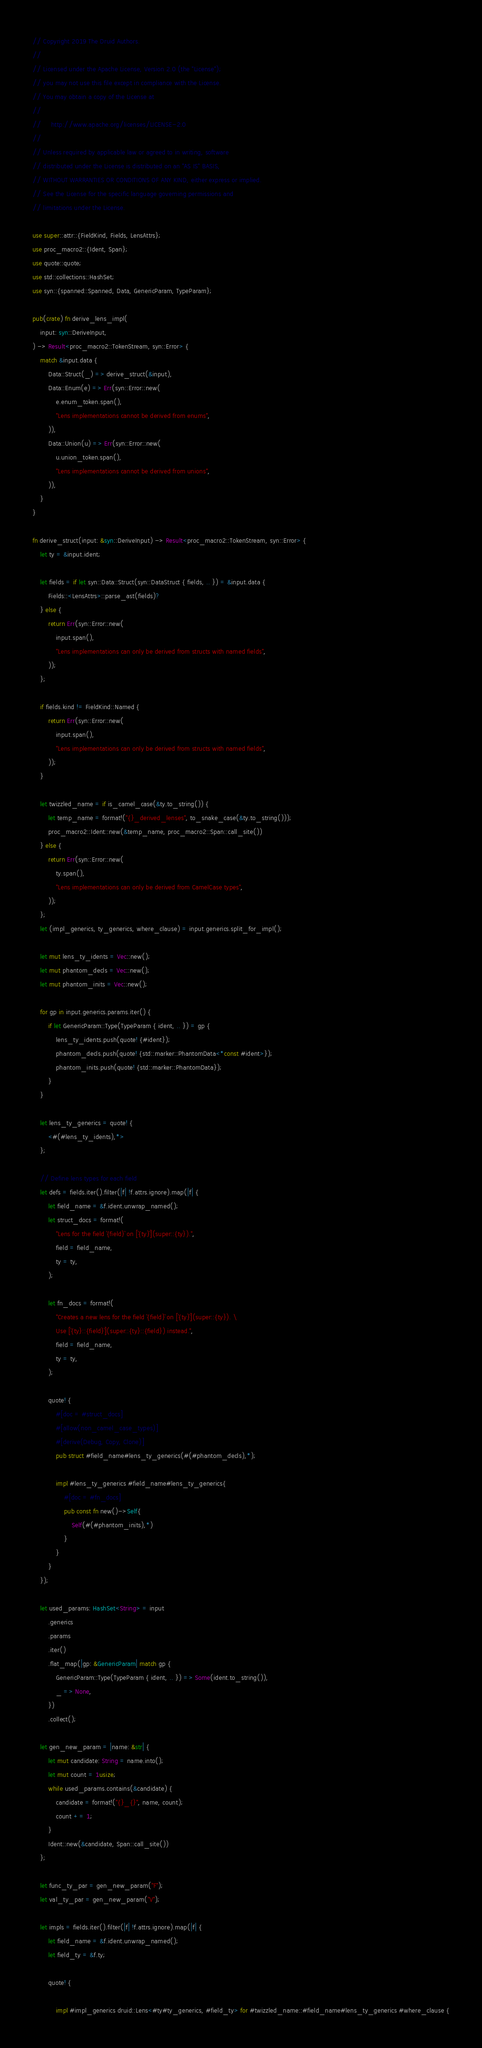<code> <loc_0><loc_0><loc_500><loc_500><_Rust_>// Copyright 2019 The Druid Authors.
//
// Licensed under the Apache License, Version 2.0 (the "License");
// you may not use this file except in compliance with the License.
// You may obtain a copy of the License at
//
//     http://www.apache.org/licenses/LICENSE-2.0
//
// Unless required by applicable law or agreed to in writing, software
// distributed under the License is distributed on an "AS IS" BASIS,
// WITHOUT WARRANTIES OR CONDITIONS OF ANY KIND, either express or implied.
// See the License for the specific language governing permissions and
// limitations under the License.

use super::attr::{FieldKind, Fields, LensAttrs};
use proc_macro2::{Ident, Span};
use quote::quote;
use std::collections::HashSet;
use syn::{spanned::Spanned, Data, GenericParam, TypeParam};

pub(crate) fn derive_lens_impl(
    input: syn::DeriveInput,
) -> Result<proc_macro2::TokenStream, syn::Error> {
    match &input.data {
        Data::Struct(_) => derive_struct(&input),
        Data::Enum(e) => Err(syn::Error::new(
            e.enum_token.span(),
            "Lens implementations cannot be derived from enums",
        )),
        Data::Union(u) => Err(syn::Error::new(
            u.union_token.span(),
            "Lens implementations cannot be derived from unions",
        )),
    }
}

fn derive_struct(input: &syn::DeriveInput) -> Result<proc_macro2::TokenStream, syn::Error> {
    let ty = &input.ident;

    let fields = if let syn::Data::Struct(syn::DataStruct { fields, .. }) = &input.data {
        Fields::<LensAttrs>::parse_ast(fields)?
    } else {
        return Err(syn::Error::new(
            input.span(),
            "Lens implementations can only be derived from structs with named fields",
        ));
    };

    if fields.kind != FieldKind::Named {
        return Err(syn::Error::new(
            input.span(),
            "Lens implementations can only be derived from structs with named fields",
        ));
    }

    let twizzled_name = if is_camel_case(&ty.to_string()) {
        let temp_name = format!("{}_derived_lenses", to_snake_case(&ty.to_string()));
        proc_macro2::Ident::new(&temp_name, proc_macro2::Span::call_site())
    } else {
        return Err(syn::Error::new(
            ty.span(),
            "Lens implementations can only be derived from CamelCase types",
        ));
    };
    let (impl_generics, ty_generics, where_clause) = input.generics.split_for_impl();

    let mut lens_ty_idents = Vec::new();
    let mut phantom_decls = Vec::new();
    let mut phantom_inits = Vec::new();

    for gp in input.generics.params.iter() {
        if let GenericParam::Type(TypeParam { ident, .. }) = gp {
            lens_ty_idents.push(quote! {#ident});
            phantom_decls.push(quote! {std::marker::PhantomData<*const #ident>});
            phantom_inits.push(quote! {std::marker::PhantomData});
        }
    }

    let lens_ty_generics = quote! {
        <#(#lens_ty_idents),*>
    };

    // Define lens types for each field
    let defs = fields.iter().filter(|f| !f.attrs.ignore).map(|f| {
        let field_name = &f.ident.unwrap_named();
        let struct_docs = format!(
            "Lens for the field `{field}` on [`{ty}`](super::{ty}).",
            field = field_name,
            ty = ty,
        );

        let fn_docs = format!(
            "Creates a new lens for the field `{field}` on [`{ty}`](super::{ty}). \
            Use [`{ty}::{field}`](super::{ty}::{field}) instead.",
            field = field_name,
            ty = ty,
        );

        quote! {
            #[doc = #struct_docs]
            #[allow(non_camel_case_types)]
            #[derive(Debug, Copy, Clone)]
            pub struct #field_name#lens_ty_generics(#(#phantom_decls),*);

            impl #lens_ty_generics #field_name#lens_ty_generics{
                #[doc = #fn_docs]
                pub const fn new()->Self{
                    Self(#(#phantom_inits),*)
                }
            }
        }
    });

    let used_params: HashSet<String> = input
        .generics
        .params
        .iter()
        .flat_map(|gp: &GenericParam| match gp {
            GenericParam::Type(TypeParam { ident, .. }) => Some(ident.to_string()),
            _ => None,
        })
        .collect();

    let gen_new_param = |name: &str| {
        let mut candidate: String = name.into();
        let mut count = 1usize;
        while used_params.contains(&candidate) {
            candidate = format!("{}_{}", name, count);
            count += 1;
        }
        Ident::new(&candidate, Span::call_site())
    };

    let func_ty_par = gen_new_param("F");
    let val_ty_par = gen_new_param("V");

    let impls = fields.iter().filter(|f| !f.attrs.ignore).map(|f| {
        let field_name = &f.ident.unwrap_named();
        let field_ty = &f.ty;

        quote! {

            impl #impl_generics druid::Lens<#ty#ty_generics, #field_ty> for #twizzled_name::#field_name#lens_ty_generics #where_clause {</code> 